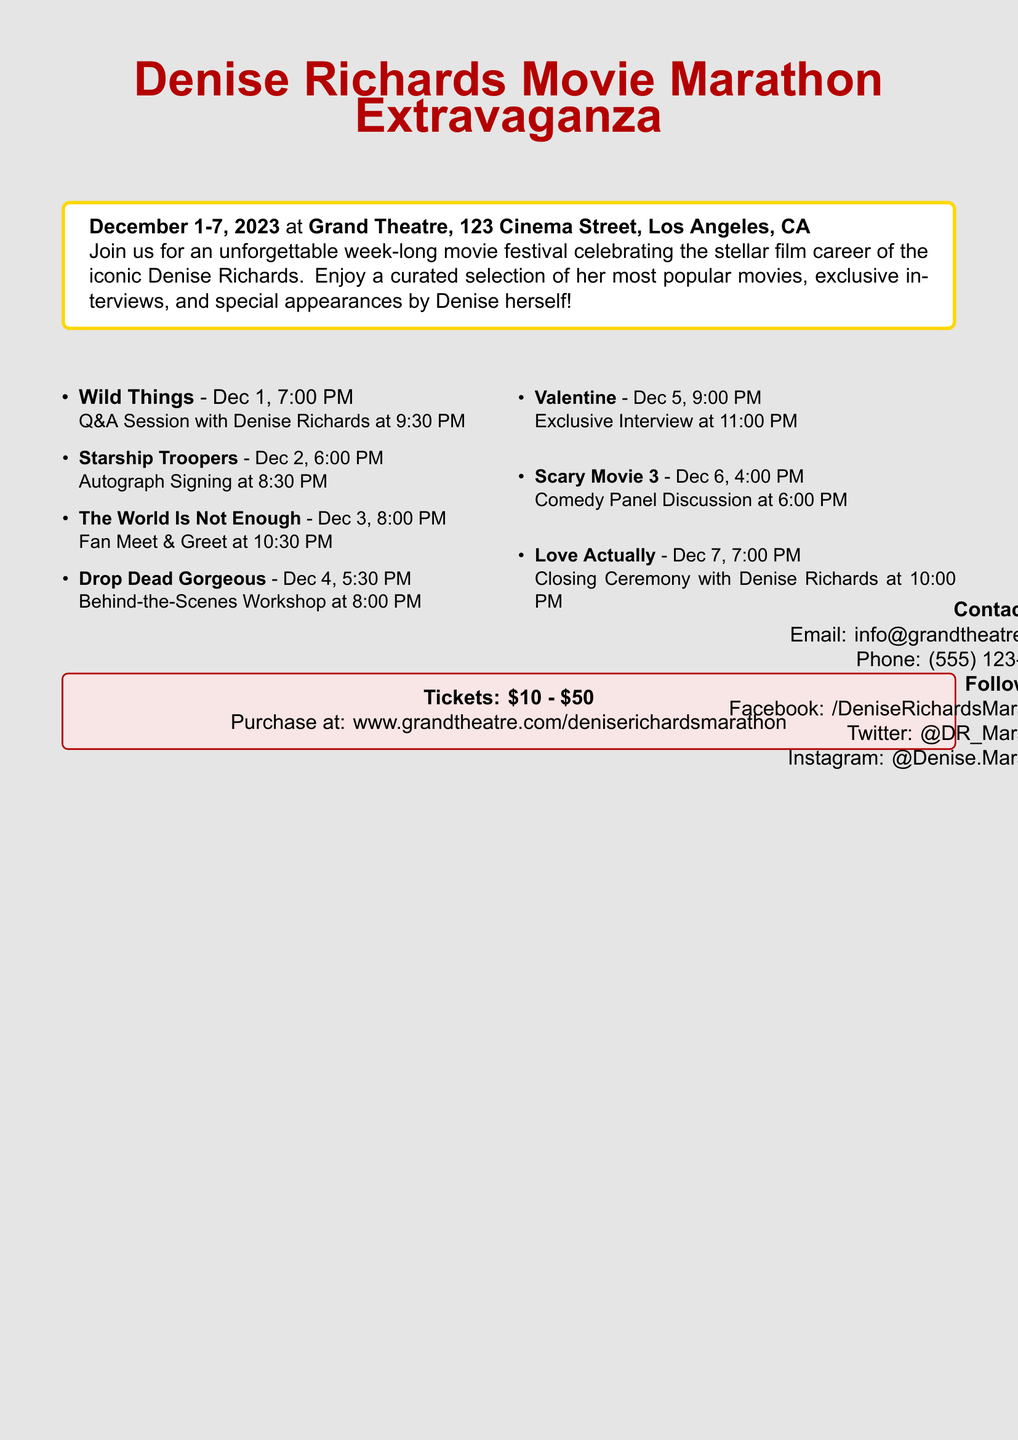What are the dates of the movie marathon? The event runs from December 1 to December 7, 2023.
Answer: December 1-7, 2023 Where is the movie marathon being held? The location of the event is stated in the document.
Answer: Grand Theatre, 123 Cinema Street, Los Angeles, CA What is the ticket price range for the marathon? The document specifies the pricing range for tickets.
Answer: $10 - $50 Which movie is being screened on December 4th? The date and corresponding movie title are listed in the schedule.
Answer: Drop Dead Gorgeous What special event occurs after the screening of 'Wild Things'? The document lists a special event taking place after this screening.
Answer: Q&A Session with Denise Richards at 9:30 PM On which day is the closing ceremony scheduled? The closing ceremony is mentioned in the document along with its date.
Answer: December 7 Which movie features Denise Richards in a fan meet and greet? The document mentions the event related to a specific movie where fans can meet Denise Richards.
Answer: The World Is Not Enough What is the website for purchasing tickets? The document provides the web address for ticket purchases.
Answer: www.grandtheatre.com/deniserichardsmarathon What type of event is included with the screening of 'Scary Movie 3'? The document details an event associated with this movie screening.
Answer: Comedy Panel Discussion 